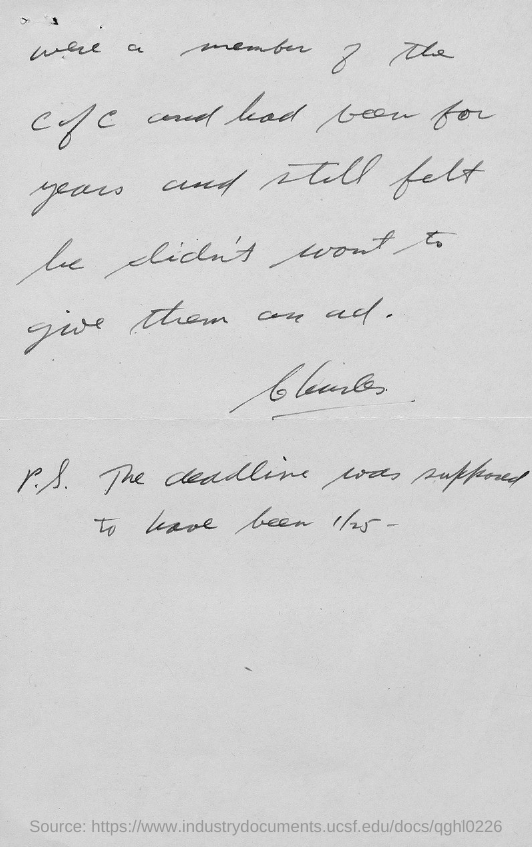Identify some key points in this picture. The number mentioned in the document is 1/25. 